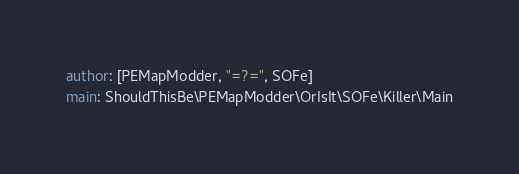Convert code to text. <code><loc_0><loc_0><loc_500><loc_500><_YAML_>author: [PEMapModder, "=?=", SOFe]
main: ShouldThisBe\PEMapModder\OrIsIt\SOFe\Killer\Main
</code> 